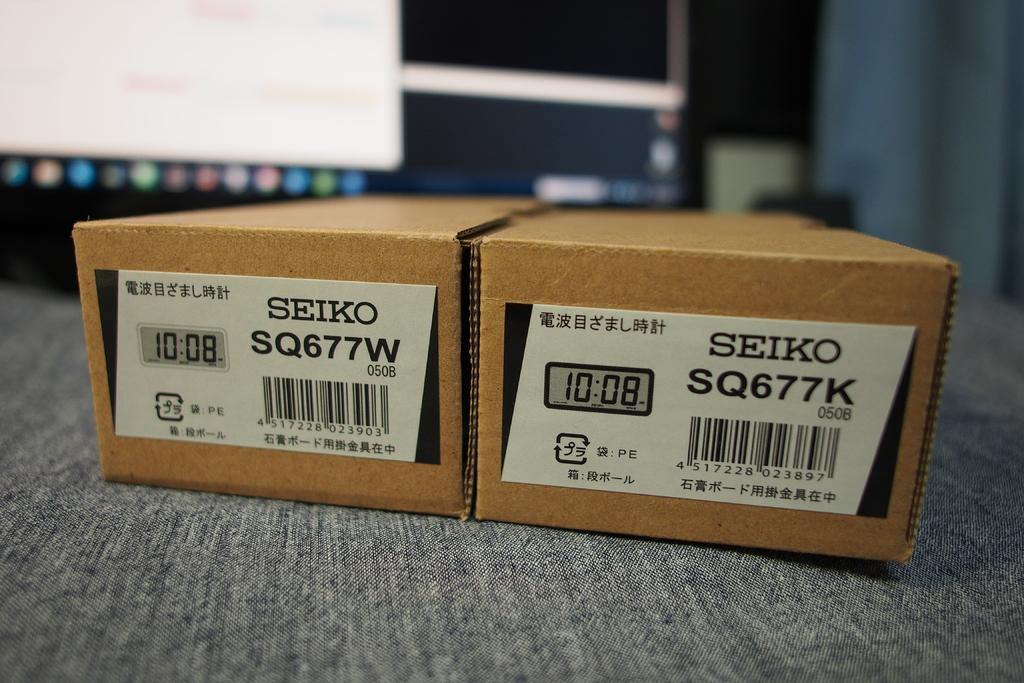<image>
Render a clear and concise summary of the photo. Two Seiko boxes sitting next to each other with the time 10:08 shown on each box. 